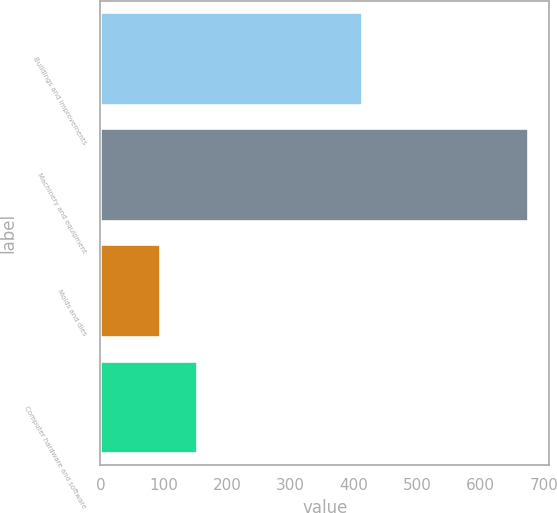Convert chart. <chart><loc_0><loc_0><loc_500><loc_500><bar_chart><fcel>Buildings and improvements<fcel>Machinery and equipment<fcel>Molds and dies<fcel>Computer hardware and software<nl><fcel>412.8<fcel>674.8<fcel>94.4<fcel>152.44<nl></chart> 